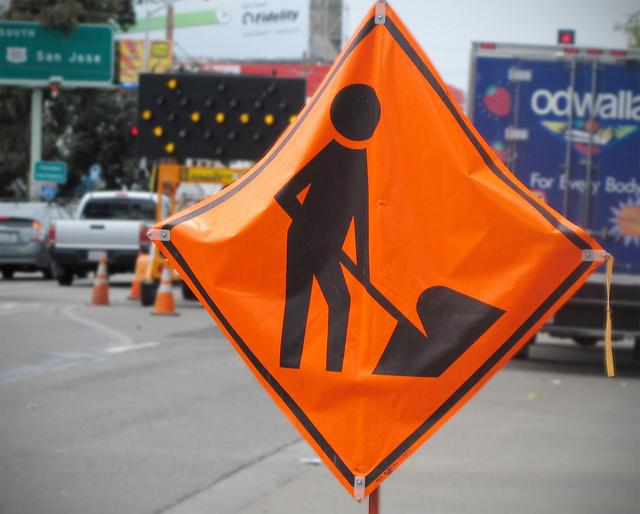What does the orange sign alert drivers of?

Choices:
A) turns prohibited
B) bike lanes
C) animal crossing
D) construction construction 